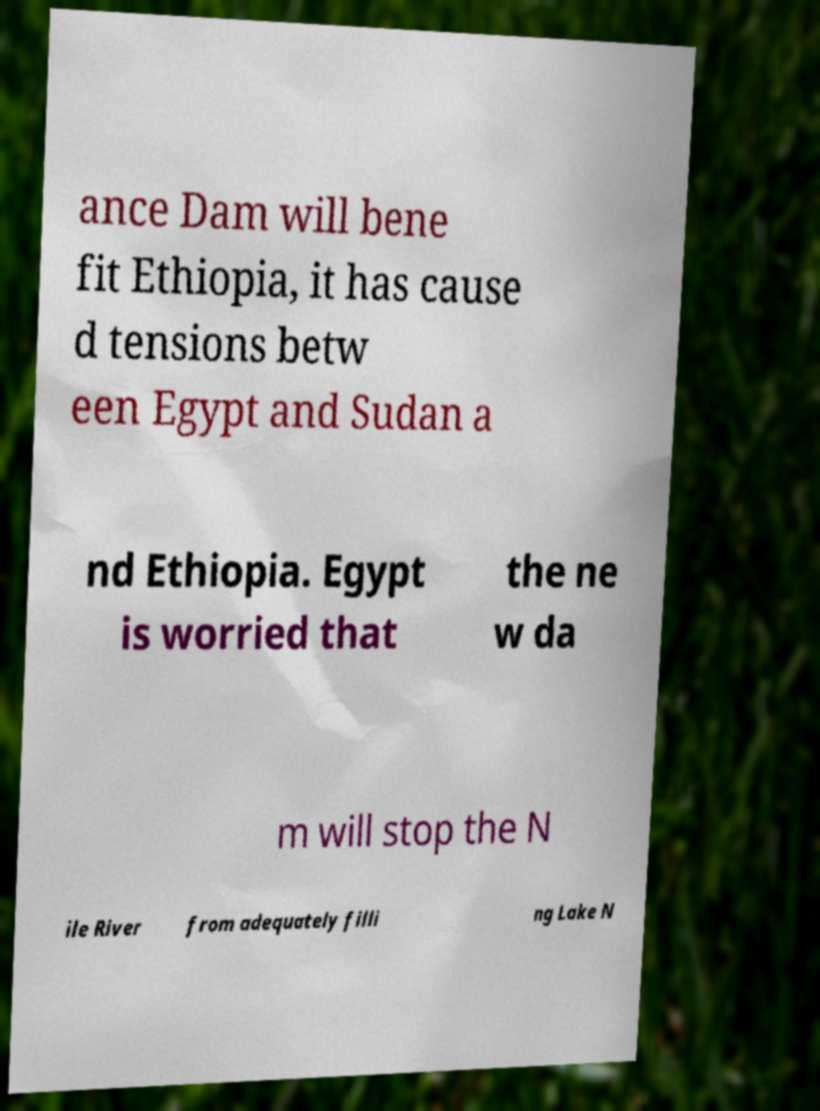There's text embedded in this image that I need extracted. Can you transcribe it verbatim? ance Dam will bene fit Ethiopia, it has cause d tensions betw een Egypt and Sudan a nd Ethiopia. Egypt is worried that the ne w da m will stop the N ile River from adequately filli ng Lake N 